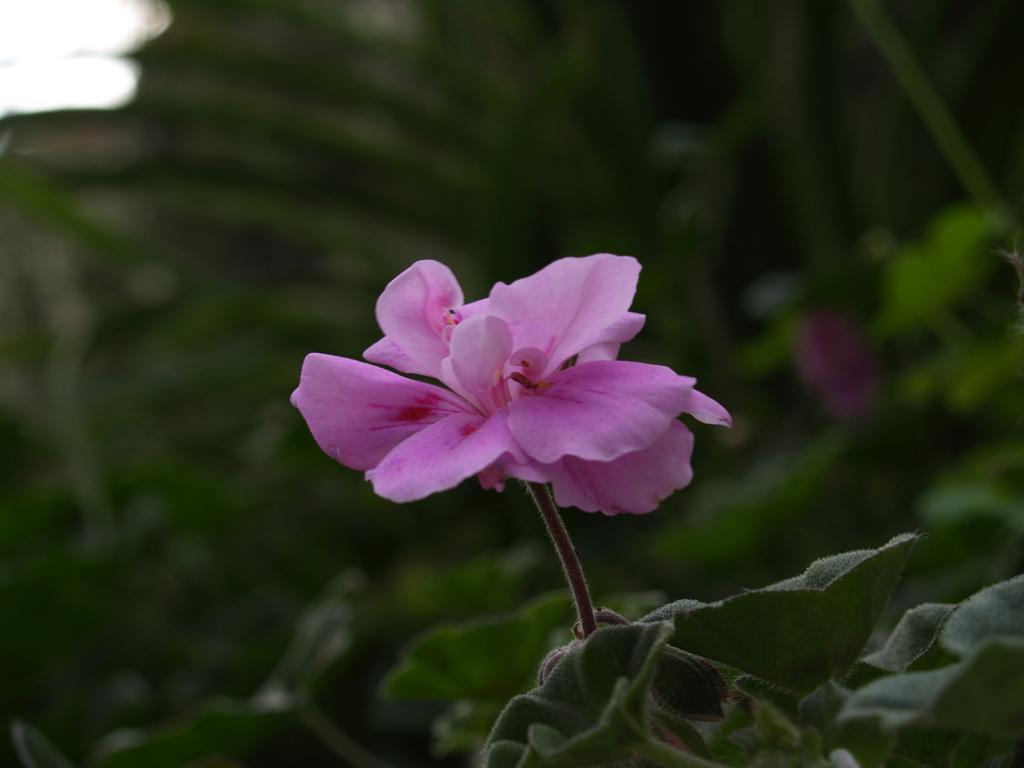Please provide a concise description of this image. In the picture we can see a plant with a flower which is pink in color with petals and in the background we can see plants which are invisible. 